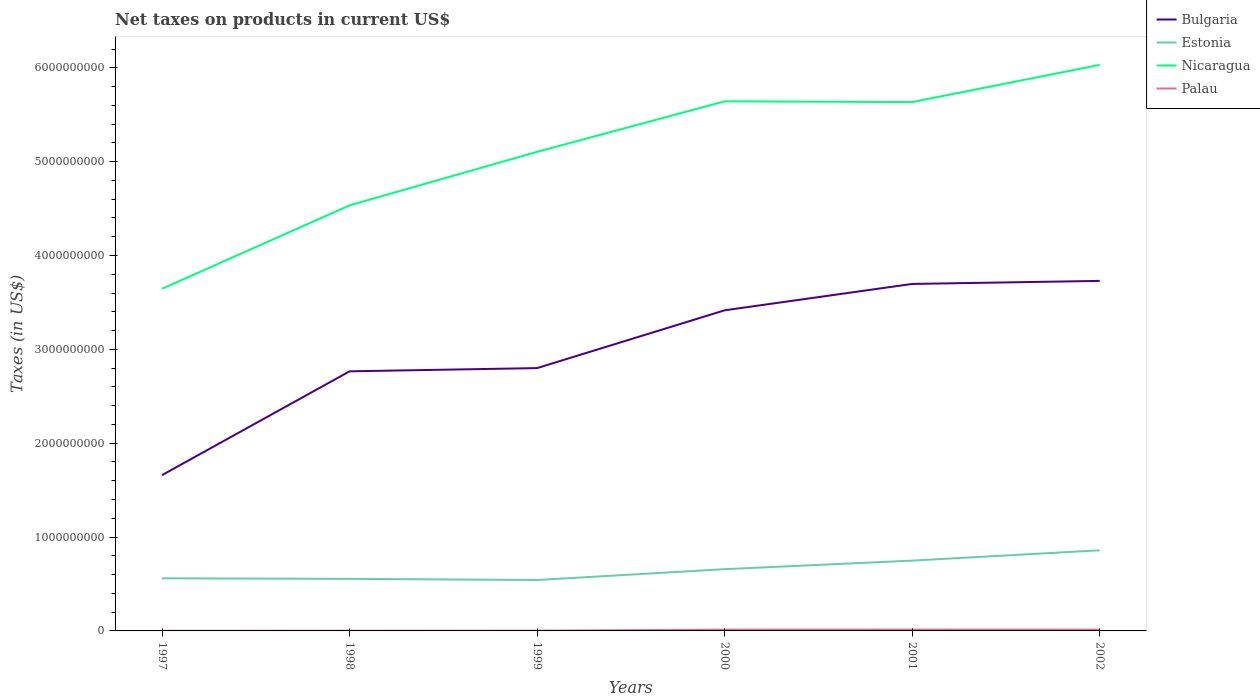Does the line corresponding to Nicaragua intersect with the line corresponding to Bulgaria?
Offer a terse response. No. Is the number of lines equal to the number of legend labels?
Make the answer very short. Yes. Across all years, what is the maximum net taxes on products in Estonia?
Make the answer very short. 5.43e+08. What is the total net taxes on products in Palau in the graph?
Your answer should be very brief. -1.20e+07. What is the difference between the highest and the second highest net taxes on products in Estonia?
Your answer should be compact. 3.17e+08. How many years are there in the graph?
Your answer should be compact. 6. Are the values on the major ticks of Y-axis written in scientific E-notation?
Offer a terse response. No. Does the graph contain grids?
Your answer should be compact. No. Where does the legend appear in the graph?
Offer a terse response. Top right. How many legend labels are there?
Provide a succinct answer. 4. What is the title of the graph?
Provide a succinct answer. Net taxes on products in current US$. What is the label or title of the X-axis?
Your response must be concise. Years. What is the label or title of the Y-axis?
Give a very brief answer. Taxes (in US$). What is the Taxes (in US$) in Bulgaria in 1997?
Offer a terse response. 1.66e+09. What is the Taxes (in US$) of Estonia in 1997?
Offer a very short reply. 5.61e+08. What is the Taxes (in US$) of Nicaragua in 1997?
Your answer should be very brief. 3.65e+09. What is the Taxes (in US$) of Palau in 1997?
Offer a terse response. 1.74e+06. What is the Taxes (in US$) in Bulgaria in 1998?
Provide a succinct answer. 2.77e+09. What is the Taxes (in US$) in Estonia in 1998?
Provide a succinct answer. 5.55e+08. What is the Taxes (in US$) of Nicaragua in 1998?
Keep it short and to the point. 4.53e+09. What is the Taxes (in US$) of Palau in 1998?
Ensure brevity in your answer.  2.23e+06. What is the Taxes (in US$) in Bulgaria in 1999?
Your answer should be very brief. 2.80e+09. What is the Taxes (in US$) of Estonia in 1999?
Offer a very short reply. 5.43e+08. What is the Taxes (in US$) of Nicaragua in 1999?
Your answer should be very brief. 5.10e+09. What is the Taxes (in US$) of Palau in 1999?
Your answer should be very brief. 2.59e+06. What is the Taxes (in US$) in Bulgaria in 2000?
Give a very brief answer. 3.42e+09. What is the Taxes (in US$) in Estonia in 2000?
Offer a very short reply. 6.58e+08. What is the Taxes (in US$) of Nicaragua in 2000?
Offer a very short reply. 5.64e+09. What is the Taxes (in US$) of Palau in 2000?
Your response must be concise. 1.38e+07. What is the Taxes (in US$) of Bulgaria in 2001?
Provide a succinct answer. 3.70e+09. What is the Taxes (in US$) of Estonia in 2001?
Your answer should be compact. 7.49e+08. What is the Taxes (in US$) in Nicaragua in 2001?
Ensure brevity in your answer.  5.63e+09. What is the Taxes (in US$) in Palau in 2001?
Your answer should be very brief. 1.46e+07. What is the Taxes (in US$) of Bulgaria in 2002?
Offer a very short reply. 3.73e+09. What is the Taxes (in US$) in Estonia in 2002?
Your response must be concise. 8.59e+08. What is the Taxes (in US$) of Nicaragua in 2002?
Provide a short and direct response. 6.03e+09. What is the Taxes (in US$) in Palau in 2002?
Offer a terse response. 1.38e+07. Across all years, what is the maximum Taxes (in US$) in Bulgaria?
Your answer should be very brief. 3.73e+09. Across all years, what is the maximum Taxes (in US$) in Estonia?
Make the answer very short. 8.59e+08. Across all years, what is the maximum Taxes (in US$) in Nicaragua?
Provide a succinct answer. 6.03e+09. Across all years, what is the maximum Taxes (in US$) in Palau?
Keep it short and to the point. 1.46e+07. Across all years, what is the minimum Taxes (in US$) of Bulgaria?
Provide a short and direct response. 1.66e+09. Across all years, what is the minimum Taxes (in US$) of Estonia?
Make the answer very short. 5.43e+08. Across all years, what is the minimum Taxes (in US$) in Nicaragua?
Keep it short and to the point. 3.65e+09. Across all years, what is the minimum Taxes (in US$) in Palau?
Your answer should be compact. 1.74e+06. What is the total Taxes (in US$) of Bulgaria in the graph?
Ensure brevity in your answer.  1.81e+1. What is the total Taxes (in US$) in Estonia in the graph?
Make the answer very short. 3.92e+09. What is the total Taxes (in US$) of Nicaragua in the graph?
Your answer should be compact. 3.06e+1. What is the total Taxes (in US$) in Palau in the graph?
Your answer should be compact. 4.87e+07. What is the difference between the Taxes (in US$) of Bulgaria in 1997 and that in 1998?
Give a very brief answer. -1.11e+09. What is the difference between the Taxes (in US$) of Estonia in 1997 and that in 1998?
Offer a very short reply. 5.90e+06. What is the difference between the Taxes (in US$) in Nicaragua in 1997 and that in 1998?
Make the answer very short. -8.88e+08. What is the difference between the Taxes (in US$) of Palau in 1997 and that in 1998?
Your answer should be compact. -4.88e+05. What is the difference between the Taxes (in US$) in Bulgaria in 1997 and that in 1999?
Your answer should be very brief. -1.14e+09. What is the difference between the Taxes (in US$) in Estonia in 1997 and that in 1999?
Provide a short and direct response. 1.81e+07. What is the difference between the Taxes (in US$) of Nicaragua in 1997 and that in 1999?
Keep it short and to the point. -1.46e+09. What is the difference between the Taxes (in US$) in Palau in 1997 and that in 1999?
Make the answer very short. -8.47e+05. What is the difference between the Taxes (in US$) of Bulgaria in 1997 and that in 2000?
Keep it short and to the point. -1.76e+09. What is the difference between the Taxes (in US$) of Estonia in 1997 and that in 2000?
Give a very brief answer. -9.72e+07. What is the difference between the Taxes (in US$) of Nicaragua in 1997 and that in 2000?
Give a very brief answer. -2.00e+09. What is the difference between the Taxes (in US$) in Palau in 1997 and that in 2000?
Your answer should be very brief. -1.21e+07. What is the difference between the Taxes (in US$) in Bulgaria in 1997 and that in 2001?
Provide a succinct answer. -2.04e+09. What is the difference between the Taxes (in US$) of Estonia in 1997 and that in 2001?
Provide a short and direct response. -1.89e+08. What is the difference between the Taxes (in US$) in Nicaragua in 1997 and that in 2001?
Your answer should be very brief. -1.99e+09. What is the difference between the Taxes (in US$) in Palau in 1997 and that in 2001?
Ensure brevity in your answer.  -1.28e+07. What is the difference between the Taxes (in US$) in Bulgaria in 1997 and that in 2002?
Your response must be concise. -2.07e+09. What is the difference between the Taxes (in US$) of Estonia in 1997 and that in 2002?
Offer a very short reply. -2.98e+08. What is the difference between the Taxes (in US$) of Nicaragua in 1997 and that in 2002?
Your response must be concise. -2.39e+09. What is the difference between the Taxes (in US$) in Palau in 1997 and that in 2002?
Give a very brief answer. -1.21e+07. What is the difference between the Taxes (in US$) in Bulgaria in 1998 and that in 1999?
Keep it short and to the point. -3.45e+07. What is the difference between the Taxes (in US$) of Estonia in 1998 and that in 1999?
Your response must be concise. 1.22e+07. What is the difference between the Taxes (in US$) of Nicaragua in 1998 and that in 1999?
Your response must be concise. -5.70e+08. What is the difference between the Taxes (in US$) of Palau in 1998 and that in 1999?
Make the answer very short. -3.59e+05. What is the difference between the Taxes (in US$) in Bulgaria in 1998 and that in 2000?
Give a very brief answer. -6.50e+08. What is the difference between the Taxes (in US$) in Estonia in 1998 and that in 2000?
Provide a succinct answer. -1.03e+08. What is the difference between the Taxes (in US$) of Nicaragua in 1998 and that in 2000?
Your answer should be compact. -1.11e+09. What is the difference between the Taxes (in US$) of Palau in 1998 and that in 2000?
Provide a short and direct response. -1.16e+07. What is the difference between the Taxes (in US$) in Bulgaria in 1998 and that in 2001?
Ensure brevity in your answer.  -9.31e+08. What is the difference between the Taxes (in US$) in Estonia in 1998 and that in 2001?
Your answer should be very brief. -1.94e+08. What is the difference between the Taxes (in US$) in Nicaragua in 1998 and that in 2001?
Offer a terse response. -1.10e+09. What is the difference between the Taxes (in US$) in Palau in 1998 and that in 2001?
Your answer should be compact. -1.23e+07. What is the difference between the Taxes (in US$) of Bulgaria in 1998 and that in 2002?
Your answer should be very brief. -9.64e+08. What is the difference between the Taxes (in US$) of Estonia in 1998 and that in 2002?
Offer a terse response. -3.04e+08. What is the difference between the Taxes (in US$) in Nicaragua in 1998 and that in 2002?
Offer a very short reply. -1.50e+09. What is the difference between the Taxes (in US$) in Palau in 1998 and that in 2002?
Offer a terse response. -1.16e+07. What is the difference between the Taxes (in US$) in Bulgaria in 1999 and that in 2000?
Give a very brief answer. -6.16e+08. What is the difference between the Taxes (in US$) in Estonia in 1999 and that in 2000?
Ensure brevity in your answer.  -1.15e+08. What is the difference between the Taxes (in US$) in Nicaragua in 1999 and that in 2000?
Provide a succinct answer. -5.38e+08. What is the difference between the Taxes (in US$) of Palau in 1999 and that in 2000?
Make the answer very short. -1.12e+07. What is the difference between the Taxes (in US$) of Bulgaria in 1999 and that in 2001?
Provide a short and direct response. -8.97e+08. What is the difference between the Taxes (in US$) in Estonia in 1999 and that in 2001?
Keep it short and to the point. -2.07e+08. What is the difference between the Taxes (in US$) in Nicaragua in 1999 and that in 2001?
Give a very brief answer. -5.30e+08. What is the difference between the Taxes (in US$) in Palau in 1999 and that in 2001?
Offer a very short reply. -1.20e+07. What is the difference between the Taxes (in US$) of Bulgaria in 1999 and that in 2002?
Ensure brevity in your answer.  -9.29e+08. What is the difference between the Taxes (in US$) in Estonia in 1999 and that in 2002?
Provide a short and direct response. -3.17e+08. What is the difference between the Taxes (in US$) in Nicaragua in 1999 and that in 2002?
Your response must be concise. -9.27e+08. What is the difference between the Taxes (in US$) of Palau in 1999 and that in 2002?
Ensure brevity in your answer.  -1.12e+07. What is the difference between the Taxes (in US$) of Bulgaria in 2000 and that in 2001?
Your response must be concise. -2.81e+08. What is the difference between the Taxes (in US$) of Estonia in 2000 and that in 2001?
Provide a succinct answer. -9.14e+07. What is the difference between the Taxes (in US$) of Nicaragua in 2000 and that in 2001?
Provide a short and direct response. 7.90e+06. What is the difference between the Taxes (in US$) in Palau in 2000 and that in 2001?
Make the answer very short. -7.40e+05. What is the difference between the Taxes (in US$) of Bulgaria in 2000 and that in 2002?
Provide a succinct answer. -3.13e+08. What is the difference between the Taxes (in US$) in Estonia in 2000 and that in 2002?
Your answer should be compact. -2.01e+08. What is the difference between the Taxes (in US$) in Nicaragua in 2000 and that in 2002?
Your answer should be compact. -3.89e+08. What is the difference between the Taxes (in US$) of Palau in 2000 and that in 2002?
Provide a short and direct response. -6792. What is the difference between the Taxes (in US$) of Bulgaria in 2001 and that in 2002?
Keep it short and to the point. -3.24e+07. What is the difference between the Taxes (in US$) in Estonia in 2001 and that in 2002?
Make the answer very short. -1.10e+08. What is the difference between the Taxes (in US$) of Nicaragua in 2001 and that in 2002?
Offer a terse response. -3.96e+08. What is the difference between the Taxes (in US$) of Palau in 2001 and that in 2002?
Ensure brevity in your answer.  7.33e+05. What is the difference between the Taxes (in US$) of Bulgaria in 1997 and the Taxes (in US$) of Estonia in 1998?
Your answer should be very brief. 1.11e+09. What is the difference between the Taxes (in US$) in Bulgaria in 1997 and the Taxes (in US$) in Nicaragua in 1998?
Offer a very short reply. -2.87e+09. What is the difference between the Taxes (in US$) of Bulgaria in 1997 and the Taxes (in US$) of Palau in 1998?
Offer a terse response. 1.66e+09. What is the difference between the Taxes (in US$) of Estonia in 1997 and the Taxes (in US$) of Nicaragua in 1998?
Make the answer very short. -3.97e+09. What is the difference between the Taxes (in US$) in Estonia in 1997 and the Taxes (in US$) in Palau in 1998?
Give a very brief answer. 5.58e+08. What is the difference between the Taxes (in US$) in Nicaragua in 1997 and the Taxes (in US$) in Palau in 1998?
Give a very brief answer. 3.64e+09. What is the difference between the Taxes (in US$) of Bulgaria in 1997 and the Taxes (in US$) of Estonia in 1999?
Your response must be concise. 1.12e+09. What is the difference between the Taxes (in US$) of Bulgaria in 1997 and the Taxes (in US$) of Nicaragua in 1999?
Offer a very short reply. -3.44e+09. What is the difference between the Taxes (in US$) of Bulgaria in 1997 and the Taxes (in US$) of Palau in 1999?
Your response must be concise. 1.66e+09. What is the difference between the Taxes (in US$) of Estonia in 1997 and the Taxes (in US$) of Nicaragua in 1999?
Ensure brevity in your answer.  -4.54e+09. What is the difference between the Taxes (in US$) in Estonia in 1997 and the Taxes (in US$) in Palau in 1999?
Offer a very short reply. 5.58e+08. What is the difference between the Taxes (in US$) of Nicaragua in 1997 and the Taxes (in US$) of Palau in 1999?
Keep it short and to the point. 3.64e+09. What is the difference between the Taxes (in US$) in Bulgaria in 1997 and the Taxes (in US$) in Estonia in 2000?
Give a very brief answer. 1.00e+09. What is the difference between the Taxes (in US$) in Bulgaria in 1997 and the Taxes (in US$) in Nicaragua in 2000?
Your response must be concise. -3.98e+09. What is the difference between the Taxes (in US$) in Bulgaria in 1997 and the Taxes (in US$) in Palau in 2000?
Your response must be concise. 1.65e+09. What is the difference between the Taxes (in US$) in Estonia in 1997 and the Taxes (in US$) in Nicaragua in 2000?
Keep it short and to the point. -5.08e+09. What is the difference between the Taxes (in US$) in Estonia in 1997 and the Taxes (in US$) in Palau in 2000?
Give a very brief answer. 5.47e+08. What is the difference between the Taxes (in US$) of Nicaragua in 1997 and the Taxes (in US$) of Palau in 2000?
Your answer should be very brief. 3.63e+09. What is the difference between the Taxes (in US$) in Bulgaria in 1997 and the Taxes (in US$) in Estonia in 2001?
Offer a terse response. 9.11e+08. What is the difference between the Taxes (in US$) in Bulgaria in 1997 and the Taxes (in US$) in Nicaragua in 2001?
Your answer should be compact. -3.97e+09. What is the difference between the Taxes (in US$) of Bulgaria in 1997 and the Taxes (in US$) of Palau in 2001?
Ensure brevity in your answer.  1.65e+09. What is the difference between the Taxes (in US$) in Estonia in 1997 and the Taxes (in US$) in Nicaragua in 2001?
Your answer should be compact. -5.07e+09. What is the difference between the Taxes (in US$) of Estonia in 1997 and the Taxes (in US$) of Palau in 2001?
Ensure brevity in your answer.  5.46e+08. What is the difference between the Taxes (in US$) of Nicaragua in 1997 and the Taxes (in US$) of Palau in 2001?
Provide a short and direct response. 3.63e+09. What is the difference between the Taxes (in US$) of Bulgaria in 1997 and the Taxes (in US$) of Estonia in 2002?
Ensure brevity in your answer.  8.01e+08. What is the difference between the Taxes (in US$) of Bulgaria in 1997 and the Taxes (in US$) of Nicaragua in 2002?
Provide a short and direct response. -4.37e+09. What is the difference between the Taxes (in US$) in Bulgaria in 1997 and the Taxes (in US$) in Palau in 2002?
Offer a terse response. 1.65e+09. What is the difference between the Taxes (in US$) in Estonia in 1997 and the Taxes (in US$) in Nicaragua in 2002?
Give a very brief answer. -5.47e+09. What is the difference between the Taxes (in US$) in Estonia in 1997 and the Taxes (in US$) in Palau in 2002?
Make the answer very short. 5.47e+08. What is the difference between the Taxes (in US$) in Nicaragua in 1997 and the Taxes (in US$) in Palau in 2002?
Provide a succinct answer. 3.63e+09. What is the difference between the Taxes (in US$) of Bulgaria in 1998 and the Taxes (in US$) of Estonia in 1999?
Your response must be concise. 2.22e+09. What is the difference between the Taxes (in US$) in Bulgaria in 1998 and the Taxes (in US$) in Nicaragua in 1999?
Keep it short and to the point. -2.34e+09. What is the difference between the Taxes (in US$) in Bulgaria in 1998 and the Taxes (in US$) in Palau in 1999?
Offer a very short reply. 2.76e+09. What is the difference between the Taxes (in US$) in Estonia in 1998 and the Taxes (in US$) in Nicaragua in 1999?
Give a very brief answer. -4.55e+09. What is the difference between the Taxes (in US$) in Estonia in 1998 and the Taxes (in US$) in Palau in 1999?
Your answer should be compact. 5.52e+08. What is the difference between the Taxes (in US$) of Nicaragua in 1998 and the Taxes (in US$) of Palau in 1999?
Give a very brief answer. 4.53e+09. What is the difference between the Taxes (in US$) of Bulgaria in 1998 and the Taxes (in US$) of Estonia in 2000?
Make the answer very short. 2.11e+09. What is the difference between the Taxes (in US$) in Bulgaria in 1998 and the Taxes (in US$) in Nicaragua in 2000?
Your answer should be very brief. -2.88e+09. What is the difference between the Taxes (in US$) of Bulgaria in 1998 and the Taxes (in US$) of Palau in 2000?
Ensure brevity in your answer.  2.75e+09. What is the difference between the Taxes (in US$) of Estonia in 1998 and the Taxes (in US$) of Nicaragua in 2000?
Make the answer very short. -5.09e+09. What is the difference between the Taxes (in US$) in Estonia in 1998 and the Taxes (in US$) in Palau in 2000?
Ensure brevity in your answer.  5.41e+08. What is the difference between the Taxes (in US$) of Nicaragua in 1998 and the Taxes (in US$) of Palau in 2000?
Make the answer very short. 4.52e+09. What is the difference between the Taxes (in US$) of Bulgaria in 1998 and the Taxes (in US$) of Estonia in 2001?
Give a very brief answer. 2.02e+09. What is the difference between the Taxes (in US$) in Bulgaria in 1998 and the Taxes (in US$) in Nicaragua in 2001?
Your answer should be very brief. -2.87e+09. What is the difference between the Taxes (in US$) in Bulgaria in 1998 and the Taxes (in US$) in Palau in 2001?
Provide a succinct answer. 2.75e+09. What is the difference between the Taxes (in US$) in Estonia in 1998 and the Taxes (in US$) in Nicaragua in 2001?
Give a very brief answer. -5.08e+09. What is the difference between the Taxes (in US$) of Estonia in 1998 and the Taxes (in US$) of Palau in 2001?
Ensure brevity in your answer.  5.40e+08. What is the difference between the Taxes (in US$) in Nicaragua in 1998 and the Taxes (in US$) in Palau in 2001?
Keep it short and to the point. 4.52e+09. What is the difference between the Taxes (in US$) of Bulgaria in 1998 and the Taxes (in US$) of Estonia in 2002?
Your response must be concise. 1.91e+09. What is the difference between the Taxes (in US$) of Bulgaria in 1998 and the Taxes (in US$) of Nicaragua in 2002?
Give a very brief answer. -3.27e+09. What is the difference between the Taxes (in US$) in Bulgaria in 1998 and the Taxes (in US$) in Palau in 2002?
Give a very brief answer. 2.75e+09. What is the difference between the Taxes (in US$) of Estonia in 1998 and the Taxes (in US$) of Nicaragua in 2002?
Give a very brief answer. -5.48e+09. What is the difference between the Taxes (in US$) of Estonia in 1998 and the Taxes (in US$) of Palau in 2002?
Your answer should be very brief. 5.41e+08. What is the difference between the Taxes (in US$) in Nicaragua in 1998 and the Taxes (in US$) in Palau in 2002?
Keep it short and to the point. 4.52e+09. What is the difference between the Taxes (in US$) in Bulgaria in 1999 and the Taxes (in US$) in Estonia in 2000?
Offer a very short reply. 2.14e+09. What is the difference between the Taxes (in US$) in Bulgaria in 1999 and the Taxes (in US$) in Nicaragua in 2000?
Offer a terse response. -2.84e+09. What is the difference between the Taxes (in US$) of Bulgaria in 1999 and the Taxes (in US$) of Palau in 2000?
Offer a very short reply. 2.79e+09. What is the difference between the Taxes (in US$) of Estonia in 1999 and the Taxes (in US$) of Nicaragua in 2000?
Your answer should be very brief. -5.10e+09. What is the difference between the Taxes (in US$) of Estonia in 1999 and the Taxes (in US$) of Palau in 2000?
Make the answer very short. 5.29e+08. What is the difference between the Taxes (in US$) of Nicaragua in 1999 and the Taxes (in US$) of Palau in 2000?
Provide a succinct answer. 5.09e+09. What is the difference between the Taxes (in US$) in Bulgaria in 1999 and the Taxes (in US$) in Estonia in 2001?
Keep it short and to the point. 2.05e+09. What is the difference between the Taxes (in US$) in Bulgaria in 1999 and the Taxes (in US$) in Nicaragua in 2001?
Provide a short and direct response. -2.83e+09. What is the difference between the Taxes (in US$) of Bulgaria in 1999 and the Taxes (in US$) of Palau in 2001?
Provide a succinct answer. 2.79e+09. What is the difference between the Taxes (in US$) in Estonia in 1999 and the Taxes (in US$) in Nicaragua in 2001?
Offer a terse response. -5.09e+09. What is the difference between the Taxes (in US$) of Estonia in 1999 and the Taxes (in US$) of Palau in 2001?
Give a very brief answer. 5.28e+08. What is the difference between the Taxes (in US$) in Nicaragua in 1999 and the Taxes (in US$) in Palau in 2001?
Give a very brief answer. 5.09e+09. What is the difference between the Taxes (in US$) of Bulgaria in 1999 and the Taxes (in US$) of Estonia in 2002?
Give a very brief answer. 1.94e+09. What is the difference between the Taxes (in US$) in Bulgaria in 1999 and the Taxes (in US$) in Nicaragua in 2002?
Offer a terse response. -3.23e+09. What is the difference between the Taxes (in US$) in Bulgaria in 1999 and the Taxes (in US$) in Palau in 2002?
Keep it short and to the point. 2.79e+09. What is the difference between the Taxes (in US$) of Estonia in 1999 and the Taxes (in US$) of Nicaragua in 2002?
Offer a very short reply. -5.49e+09. What is the difference between the Taxes (in US$) of Estonia in 1999 and the Taxes (in US$) of Palau in 2002?
Offer a very short reply. 5.29e+08. What is the difference between the Taxes (in US$) of Nicaragua in 1999 and the Taxes (in US$) of Palau in 2002?
Your answer should be compact. 5.09e+09. What is the difference between the Taxes (in US$) in Bulgaria in 2000 and the Taxes (in US$) in Estonia in 2001?
Ensure brevity in your answer.  2.67e+09. What is the difference between the Taxes (in US$) of Bulgaria in 2000 and the Taxes (in US$) of Nicaragua in 2001?
Ensure brevity in your answer.  -2.22e+09. What is the difference between the Taxes (in US$) in Bulgaria in 2000 and the Taxes (in US$) in Palau in 2001?
Ensure brevity in your answer.  3.40e+09. What is the difference between the Taxes (in US$) in Estonia in 2000 and the Taxes (in US$) in Nicaragua in 2001?
Provide a short and direct response. -4.98e+09. What is the difference between the Taxes (in US$) of Estonia in 2000 and the Taxes (in US$) of Palau in 2001?
Offer a very short reply. 6.43e+08. What is the difference between the Taxes (in US$) in Nicaragua in 2000 and the Taxes (in US$) in Palau in 2001?
Ensure brevity in your answer.  5.63e+09. What is the difference between the Taxes (in US$) in Bulgaria in 2000 and the Taxes (in US$) in Estonia in 2002?
Offer a very short reply. 2.56e+09. What is the difference between the Taxes (in US$) of Bulgaria in 2000 and the Taxes (in US$) of Nicaragua in 2002?
Keep it short and to the point. -2.62e+09. What is the difference between the Taxes (in US$) in Bulgaria in 2000 and the Taxes (in US$) in Palau in 2002?
Offer a very short reply. 3.40e+09. What is the difference between the Taxes (in US$) in Estonia in 2000 and the Taxes (in US$) in Nicaragua in 2002?
Offer a terse response. -5.37e+09. What is the difference between the Taxes (in US$) of Estonia in 2000 and the Taxes (in US$) of Palau in 2002?
Your answer should be very brief. 6.44e+08. What is the difference between the Taxes (in US$) of Nicaragua in 2000 and the Taxes (in US$) of Palau in 2002?
Keep it short and to the point. 5.63e+09. What is the difference between the Taxes (in US$) of Bulgaria in 2001 and the Taxes (in US$) of Estonia in 2002?
Offer a terse response. 2.84e+09. What is the difference between the Taxes (in US$) in Bulgaria in 2001 and the Taxes (in US$) in Nicaragua in 2002?
Offer a very short reply. -2.33e+09. What is the difference between the Taxes (in US$) in Bulgaria in 2001 and the Taxes (in US$) in Palau in 2002?
Provide a short and direct response. 3.68e+09. What is the difference between the Taxes (in US$) of Estonia in 2001 and the Taxes (in US$) of Nicaragua in 2002?
Make the answer very short. -5.28e+09. What is the difference between the Taxes (in US$) in Estonia in 2001 and the Taxes (in US$) in Palau in 2002?
Ensure brevity in your answer.  7.35e+08. What is the difference between the Taxes (in US$) in Nicaragua in 2001 and the Taxes (in US$) in Palau in 2002?
Your answer should be very brief. 5.62e+09. What is the average Taxes (in US$) in Bulgaria per year?
Your answer should be very brief. 3.01e+09. What is the average Taxes (in US$) of Estonia per year?
Your answer should be very brief. 6.54e+08. What is the average Taxes (in US$) of Nicaragua per year?
Offer a terse response. 5.10e+09. What is the average Taxes (in US$) in Palau per year?
Ensure brevity in your answer.  8.12e+06. In the year 1997, what is the difference between the Taxes (in US$) in Bulgaria and Taxes (in US$) in Estonia?
Keep it short and to the point. 1.10e+09. In the year 1997, what is the difference between the Taxes (in US$) in Bulgaria and Taxes (in US$) in Nicaragua?
Provide a short and direct response. -1.99e+09. In the year 1997, what is the difference between the Taxes (in US$) of Bulgaria and Taxes (in US$) of Palau?
Your answer should be very brief. 1.66e+09. In the year 1997, what is the difference between the Taxes (in US$) of Estonia and Taxes (in US$) of Nicaragua?
Give a very brief answer. -3.09e+09. In the year 1997, what is the difference between the Taxes (in US$) of Estonia and Taxes (in US$) of Palau?
Give a very brief answer. 5.59e+08. In the year 1997, what is the difference between the Taxes (in US$) of Nicaragua and Taxes (in US$) of Palau?
Ensure brevity in your answer.  3.64e+09. In the year 1998, what is the difference between the Taxes (in US$) in Bulgaria and Taxes (in US$) in Estonia?
Keep it short and to the point. 2.21e+09. In the year 1998, what is the difference between the Taxes (in US$) in Bulgaria and Taxes (in US$) in Nicaragua?
Give a very brief answer. -1.77e+09. In the year 1998, what is the difference between the Taxes (in US$) of Bulgaria and Taxes (in US$) of Palau?
Give a very brief answer. 2.76e+09. In the year 1998, what is the difference between the Taxes (in US$) in Estonia and Taxes (in US$) in Nicaragua?
Keep it short and to the point. -3.98e+09. In the year 1998, what is the difference between the Taxes (in US$) in Estonia and Taxes (in US$) in Palau?
Keep it short and to the point. 5.52e+08. In the year 1998, what is the difference between the Taxes (in US$) of Nicaragua and Taxes (in US$) of Palau?
Make the answer very short. 4.53e+09. In the year 1999, what is the difference between the Taxes (in US$) of Bulgaria and Taxes (in US$) of Estonia?
Give a very brief answer. 2.26e+09. In the year 1999, what is the difference between the Taxes (in US$) of Bulgaria and Taxes (in US$) of Nicaragua?
Your answer should be compact. -2.30e+09. In the year 1999, what is the difference between the Taxes (in US$) of Bulgaria and Taxes (in US$) of Palau?
Provide a short and direct response. 2.80e+09. In the year 1999, what is the difference between the Taxes (in US$) of Estonia and Taxes (in US$) of Nicaragua?
Provide a succinct answer. -4.56e+09. In the year 1999, what is the difference between the Taxes (in US$) of Estonia and Taxes (in US$) of Palau?
Offer a terse response. 5.40e+08. In the year 1999, what is the difference between the Taxes (in US$) of Nicaragua and Taxes (in US$) of Palau?
Your response must be concise. 5.10e+09. In the year 2000, what is the difference between the Taxes (in US$) in Bulgaria and Taxes (in US$) in Estonia?
Your response must be concise. 2.76e+09. In the year 2000, what is the difference between the Taxes (in US$) in Bulgaria and Taxes (in US$) in Nicaragua?
Offer a terse response. -2.23e+09. In the year 2000, what is the difference between the Taxes (in US$) of Bulgaria and Taxes (in US$) of Palau?
Provide a short and direct response. 3.40e+09. In the year 2000, what is the difference between the Taxes (in US$) in Estonia and Taxes (in US$) in Nicaragua?
Give a very brief answer. -4.98e+09. In the year 2000, what is the difference between the Taxes (in US$) in Estonia and Taxes (in US$) in Palau?
Keep it short and to the point. 6.44e+08. In the year 2000, what is the difference between the Taxes (in US$) in Nicaragua and Taxes (in US$) in Palau?
Your answer should be very brief. 5.63e+09. In the year 2001, what is the difference between the Taxes (in US$) of Bulgaria and Taxes (in US$) of Estonia?
Offer a very short reply. 2.95e+09. In the year 2001, what is the difference between the Taxes (in US$) of Bulgaria and Taxes (in US$) of Nicaragua?
Provide a succinct answer. -1.94e+09. In the year 2001, what is the difference between the Taxes (in US$) in Bulgaria and Taxes (in US$) in Palau?
Make the answer very short. 3.68e+09. In the year 2001, what is the difference between the Taxes (in US$) of Estonia and Taxes (in US$) of Nicaragua?
Your answer should be compact. -4.89e+09. In the year 2001, what is the difference between the Taxes (in US$) in Estonia and Taxes (in US$) in Palau?
Make the answer very short. 7.35e+08. In the year 2001, what is the difference between the Taxes (in US$) in Nicaragua and Taxes (in US$) in Palau?
Give a very brief answer. 5.62e+09. In the year 2002, what is the difference between the Taxes (in US$) of Bulgaria and Taxes (in US$) of Estonia?
Give a very brief answer. 2.87e+09. In the year 2002, what is the difference between the Taxes (in US$) in Bulgaria and Taxes (in US$) in Nicaragua?
Your answer should be compact. -2.30e+09. In the year 2002, what is the difference between the Taxes (in US$) of Bulgaria and Taxes (in US$) of Palau?
Provide a short and direct response. 3.72e+09. In the year 2002, what is the difference between the Taxes (in US$) in Estonia and Taxes (in US$) in Nicaragua?
Make the answer very short. -5.17e+09. In the year 2002, what is the difference between the Taxes (in US$) in Estonia and Taxes (in US$) in Palau?
Offer a terse response. 8.45e+08. In the year 2002, what is the difference between the Taxes (in US$) in Nicaragua and Taxes (in US$) in Palau?
Your answer should be very brief. 6.02e+09. What is the ratio of the Taxes (in US$) in Bulgaria in 1997 to that in 1998?
Ensure brevity in your answer.  0.6. What is the ratio of the Taxes (in US$) in Estonia in 1997 to that in 1998?
Offer a terse response. 1.01. What is the ratio of the Taxes (in US$) in Nicaragua in 1997 to that in 1998?
Keep it short and to the point. 0.8. What is the ratio of the Taxes (in US$) in Palau in 1997 to that in 1998?
Keep it short and to the point. 0.78. What is the ratio of the Taxes (in US$) in Bulgaria in 1997 to that in 1999?
Give a very brief answer. 0.59. What is the ratio of the Taxes (in US$) in Estonia in 1997 to that in 1999?
Make the answer very short. 1.03. What is the ratio of the Taxes (in US$) in Nicaragua in 1997 to that in 1999?
Give a very brief answer. 0.71. What is the ratio of the Taxes (in US$) in Palau in 1997 to that in 1999?
Your answer should be very brief. 0.67. What is the ratio of the Taxes (in US$) in Bulgaria in 1997 to that in 2000?
Your answer should be very brief. 0.49. What is the ratio of the Taxes (in US$) in Estonia in 1997 to that in 2000?
Provide a succinct answer. 0.85. What is the ratio of the Taxes (in US$) of Nicaragua in 1997 to that in 2000?
Your answer should be very brief. 0.65. What is the ratio of the Taxes (in US$) in Palau in 1997 to that in 2000?
Provide a succinct answer. 0.13. What is the ratio of the Taxes (in US$) of Bulgaria in 1997 to that in 2001?
Keep it short and to the point. 0.45. What is the ratio of the Taxes (in US$) of Estonia in 1997 to that in 2001?
Your response must be concise. 0.75. What is the ratio of the Taxes (in US$) in Nicaragua in 1997 to that in 2001?
Your answer should be very brief. 0.65. What is the ratio of the Taxes (in US$) in Palau in 1997 to that in 2001?
Make the answer very short. 0.12. What is the ratio of the Taxes (in US$) of Bulgaria in 1997 to that in 2002?
Offer a terse response. 0.45. What is the ratio of the Taxes (in US$) in Estonia in 1997 to that in 2002?
Keep it short and to the point. 0.65. What is the ratio of the Taxes (in US$) in Nicaragua in 1997 to that in 2002?
Offer a terse response. 0.6. What is the ratio of the Taxes (in US$) of Palau in 1997 to that in 2002?
Provide a short and direct response. 0.13. What is the ratio of the Taxes (in US$) in Bulgaria in 1998 to that in 1999?
Keep it short and to the point. 0.99. What is the ratio of the Taxes (in US$) of Estonia in 1998 to that in 1999?
Offer a very short reply. 1.02. What is the ratio of the Taxes (in US$) of Nicaragua in 1998 to that in 1999?
Offer a terse response. 0.89. What is the ratio of the Taxes (in US$) in Palau in 1998 to that in 1999?
Ensure brevity in your answer.  0.86. What is the ratio of the Taxes (in US$) in Bulgaria in 1998 to that in 2000?
Make the answer very short. 0.81. What is the ratio of the Taxes (in US$) of Estonia in 1998 to that in 2000?
Your answer should be compact. 0.84. What is the ratio of the Taxes (in US$) of Nicaragua in 1998 to that in 2000?
Offer a very short reply. 0.8. What is the ratio of the Taxes (in US$) of Palau in 1998 to that in 2000?
Make the answer very short. 0.16. What is the ratio of the Taxes (in US$) in Bulgaria in 1998 to that in 2001?
Ensure brevity in your answer.  0.75. What is the ratio of the Taxes (in US$) in Estonia in 1998 to that in 2001?
Keep it short and to the point. 0.74. What is the ratio of the Taxes (in US$) of Nicaragua in 1998 to that in 2001?
Your response must be concise. 0.8. What is the ratio of the Taxes (in US$) of Palau in 1998 to that in 2001?
Your answer should be very brief. 0.15. What is the ratio of the Taxes (in US$) in Bulgaria in 1998 to that in 2002?
Offer a terse response. 0.74. What is the ratio of the Taxes (in US$) of Estonia in 1998 to that in 2002?
Your answer should be compact. 0.65. What is the ratio of the Taxes (in US$) of Nicaragua in 1998 to that in 2002?
Provide a succinct answer. 0.75. What is the ratio of the Taxes (in US$) in Palau in 1998 to that in 2002?
Offer a very short reply. 0.16. What is the ratio of the Taxes (in US$) in Bulgaria in 1999 to that in 2000?
Give a very brief answer. 0.82. What is the ratio of the Taxes (in US$) in Estonia in 1999 to that in 2000?
Provide a short and direct response. 0.82. What is the ratio of the Taxes (in US$) of Nicaragua in 1999 to that in 2000?
Offer a very short reply. 0.9. What is the ratio of the Taxes (in US$) in Palau in 1999 to that in 2000?
Keep it short and to the point. 0.19. What is the ratio of the Taxes (in US$) of Bulgaria in 1999 to that in 2001?
Your answer should be compact. 0.76. What is the ratio of the Taxes (in US$) in Estonia in 1999 to that in 2001?
Ensure brevity in your answer.  0.72. What is the ratio of the Taxes (in US$) in Nicaragua in 1999 to that in 2001?
Provide a short and direct response. 0.91. What is the ratio of the Taxes (in US$) of Palau in 1999 to that in 2001?
Your answer should be compact. 0.18. What is the ratio of the Taxes (in US$) in Bulgaria in 1999 to that in 2002?
Ensure brevity in your answer.  0.75. What is the ratio of the Taxes (in US$) in Estonia in 1999 to that in 2002?
Ensure brevity in your answer.  0.63. What is the ratio of the Taxes (in US$) of Nicaragua in 1999 to that in 2002?
Ensure brevity in your answer.  0.85. What is the ratio of the Taxes (in US$) in Palau in 1999 to that in 2002?
Give a very brief answer. 0.19. What is the ratio of the Taxes (in US$) of Bulgaria in 2000 to that in 2001?
Offer a terse response. 0.92. What is the ratio of the Taxes (in US$) of Estonia in 2000 to that in 2001?
Keep it short and to the point. 0.88. What is the ratio of the Taxes (in US$) in Palau in 2000 to that in 2001?
Provide a short and direct response. 0.95. What is the ratio of the Taxes (in US$) in Bulgaria in 2000 to that in 2002?
Provide a short and direct response. 0.92. What is the ratio of the Taxes (in US$) of Estonia in 2000 to that in 2002?
Give a very brief answer. 0.77. What is the ratio of the Taxes (in US$) of Nicaragua in 2000 to that in 2002?
Offer a very short reply. 0.94. What is the ratio of the Taxes (in US$) in Estonia in 2001 to that in 2002?
Your answer should be very brief. 0.87. What is the ratio of the Taxes (in US$) of Nicaragua in 2001 to that in 2002?
Provide a short and direct response. 0.93. What is the ratio of the Taxes (in US$) in Palau in 2001 to that in 2002?
Keep it short and to the point. 1.05. What is the difference between the highest and the second highest Taxes (in US$) in Bulgaria?
Provide a short and direct response. 3.24e+07. What is the difference between the highest and the second highest Taxes (in US$) of Estonia?
Give a very brief answer. 1.10e+08. What is the difference between the highest and the second highest Taxes (in US$) in Nicaragua?
Provide a succinct answer. 3.89e+08. What is the difference between the highest and the second highest Taxes (in US$) in Palau?
Provide a short and direct response. 7.33e+05. What is the difference between the highest and the lowest Taxes (in US$) in Bulgaria?
Your answer should be compact. 2.07e+09. What is the difference between the highest and the lowest Taxes (in US$) of Estonia?
Provide a short and direct response. 3.17e+08. What is the difference between the highest and the lowest Taxes (in US$) of Nicaragua?
Offer a terse response. 2.39e+09. What is the difference between the highest and the lowest Taxes (in US$) in Palau?
Provide a short and direct response. 1.28e+07. 